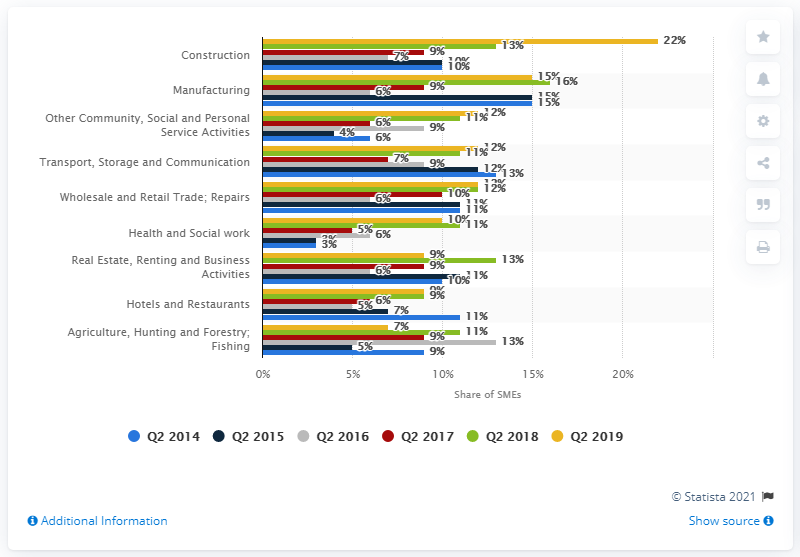Highlight a few significant elements in this photo. According to the survey, 22% of SMEs believed that cash flow and issues with late payment would be a major obstacle hindering their ability to run their business in the next 12 months. 